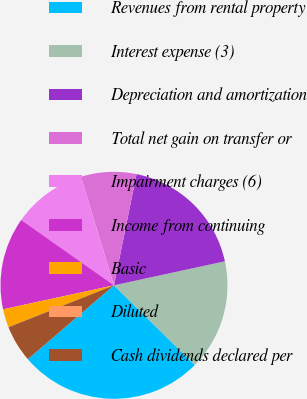Convert chart to OTSL. <chart><loc_0><loc_0><loc_500><loc_500><pie_chart><fcel>Revenues from rental property<fcel>Interest expense (3)<fcel>Depreciation and amortization<fcel>Total net gain on transfer or<fcel>Impairment charges (6)<fcel>Income from continuing<fcel>Basic<fcel>Diluted<fcel>Cash dividends declared per<nl><fcel>26.32%<fcel>15.79%<fcel>18.42%<fcel>7.89%<fcel>10.53%<fcel>13.16%<fcel>2.63%<fcel>0.0%<fcel>5.26%<nl></chart> 